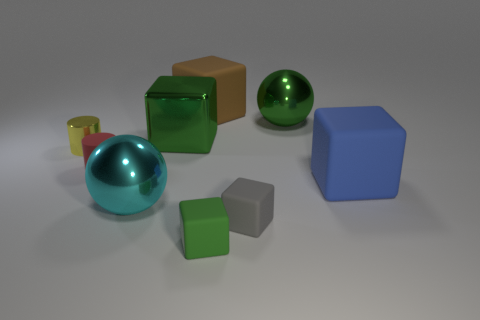Subtract all green cubes. How many cubes are left? 3 Subtract all green blocks. How many blocks are left? 3 Subtract 2 cubes. How many cubes are left? 3 Subtract all cubes. How many objects are left? 4 Subtract all cyan balls. How many purple cylinders are left? 0 Subtract all purple cylinders. Subtract all brown cubes. How many cylinders are left? 2 Add 7 gray metal blocks. How many gray metal blocks exist? 7 Subtract 0 brown cylinders. How many objects are left? 9 Subtract all cyan matte things. Subtract all tiny cylinders. How many objects are left? 7 Add 2 small metallic objects. How many small metallic objects are left? 3 